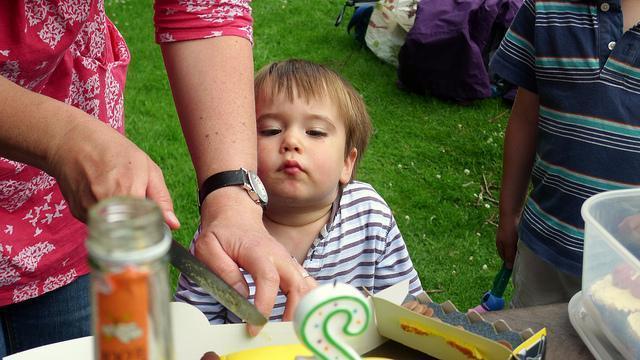How many cakes are there?
Give a very brief answer. 2. How many people are there?
Give a very brief answer. 3. How many knives can be seen?
Give a very brief answer. 1. 